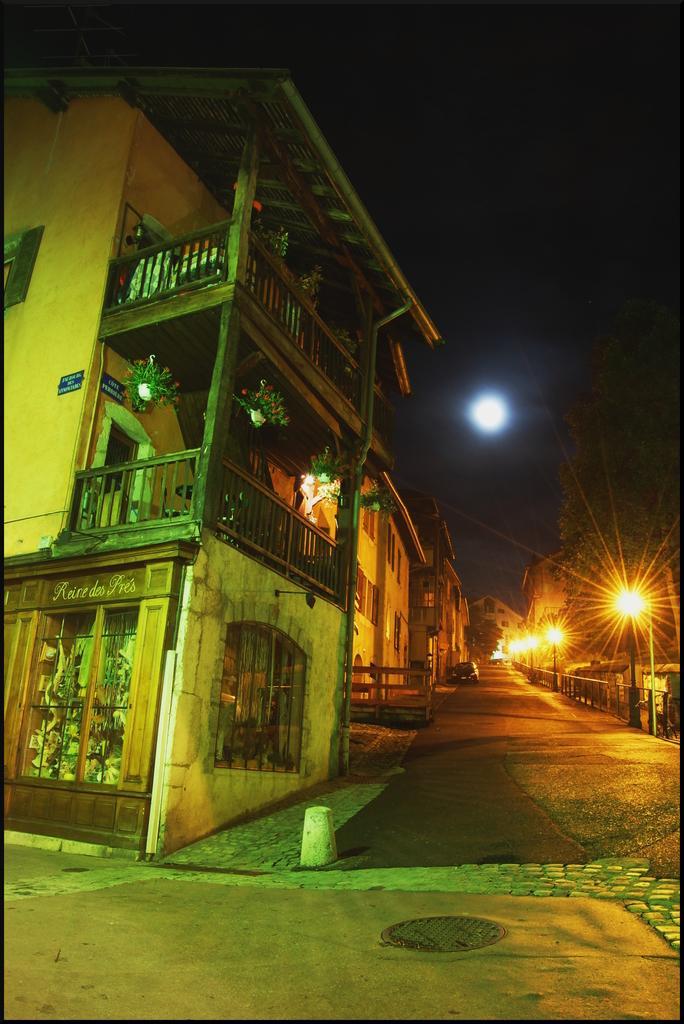Could you give a brief overview of what you see in this image? In this picture I can see the buildings on the left side, in the background there is a car. On the right side there are lights, trees. At the top I can see the moon in the sky. 